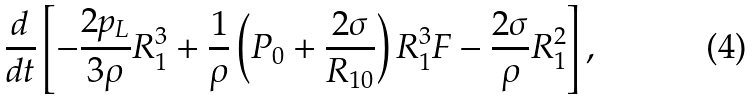Convert formula to latex. <formula><loc_0><loc_0><loc_500><loc_500>\frac { d } { d t } \left [ { - \frac { 2 p _ { L } } { 3 \rho } R _ { 1 } ^ { 3 } + \frac { 1 } { \rho } \left ( { P _ { 0 } + \frac { 2 \sigma } { R _ { 1 0 } } } \right ) R _ { 1 } ^ { 3 } F - \frac { 2 \sigma } { \rho } R _ { 1 } ^ { 2 } } \right ] ,</formula> 